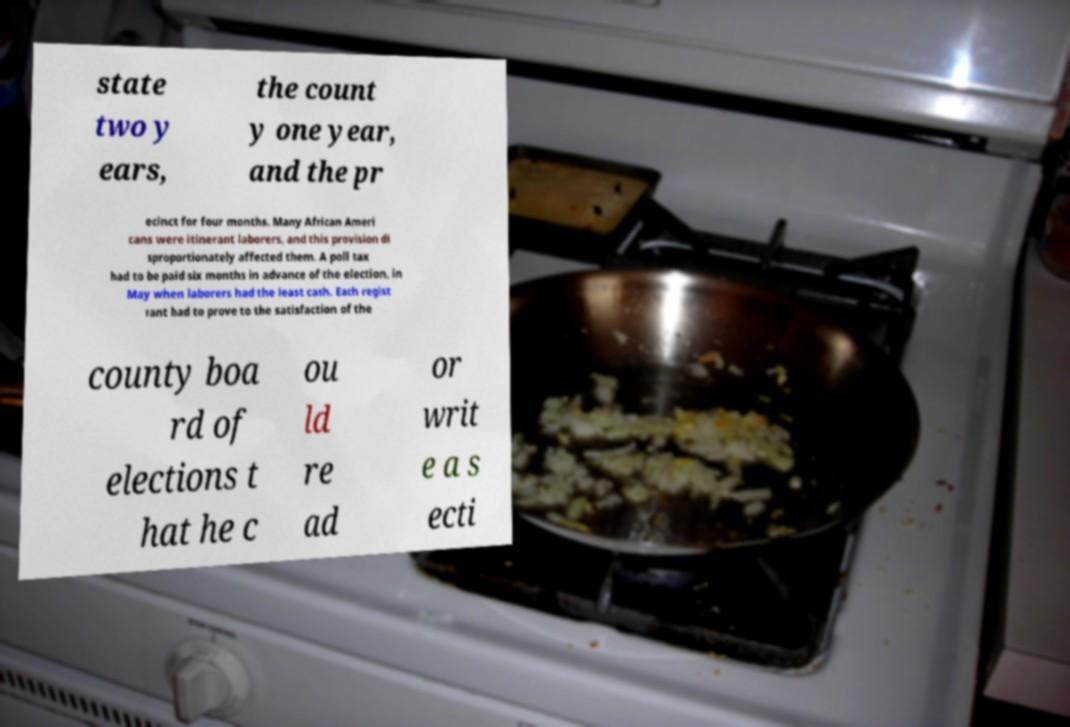For documentation purposes, I need the text within this image transcribed. Could you provide that? state two y ears, the count y one year, and the pr ecinct for four months. Many African Ameri cans were itinerant laborers, and this provision di sproportionately affected them. A poll tax had to be paid six months in advance of the election, in May when laborers had the least cash. Each regist rant had to prove to the satisfaction of the county boa rd of elections t hat he c ou ld re ad or writ e a s ecti 